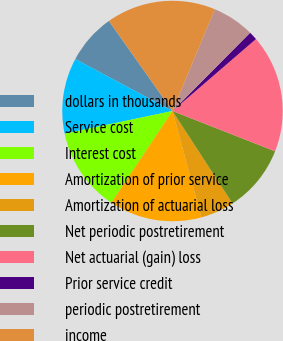<chart> <loc_0><loc_0><loc_500><loc_500><pie_chart><fcel>dollars in thousands<fcel>Service cost<fcel>Interest cost<fcel>Amortization of prior service<fcel>Amortization of actuarial loss<fcel>Net periodic postretirement<fcel>Net actuarial (gain) loss<fcel>Prior service credit<fcel>periodic postretirement<fcel>income<nl><fcel>7.41%<fcel>11.11%<fcel>12.35%<fcel>13.58%<fcel>4.94%<fcel>9.88%<fcel>17.28%<fcel>1.24%<fcel>6.17%<fcel>16.05%<nl></chart> 